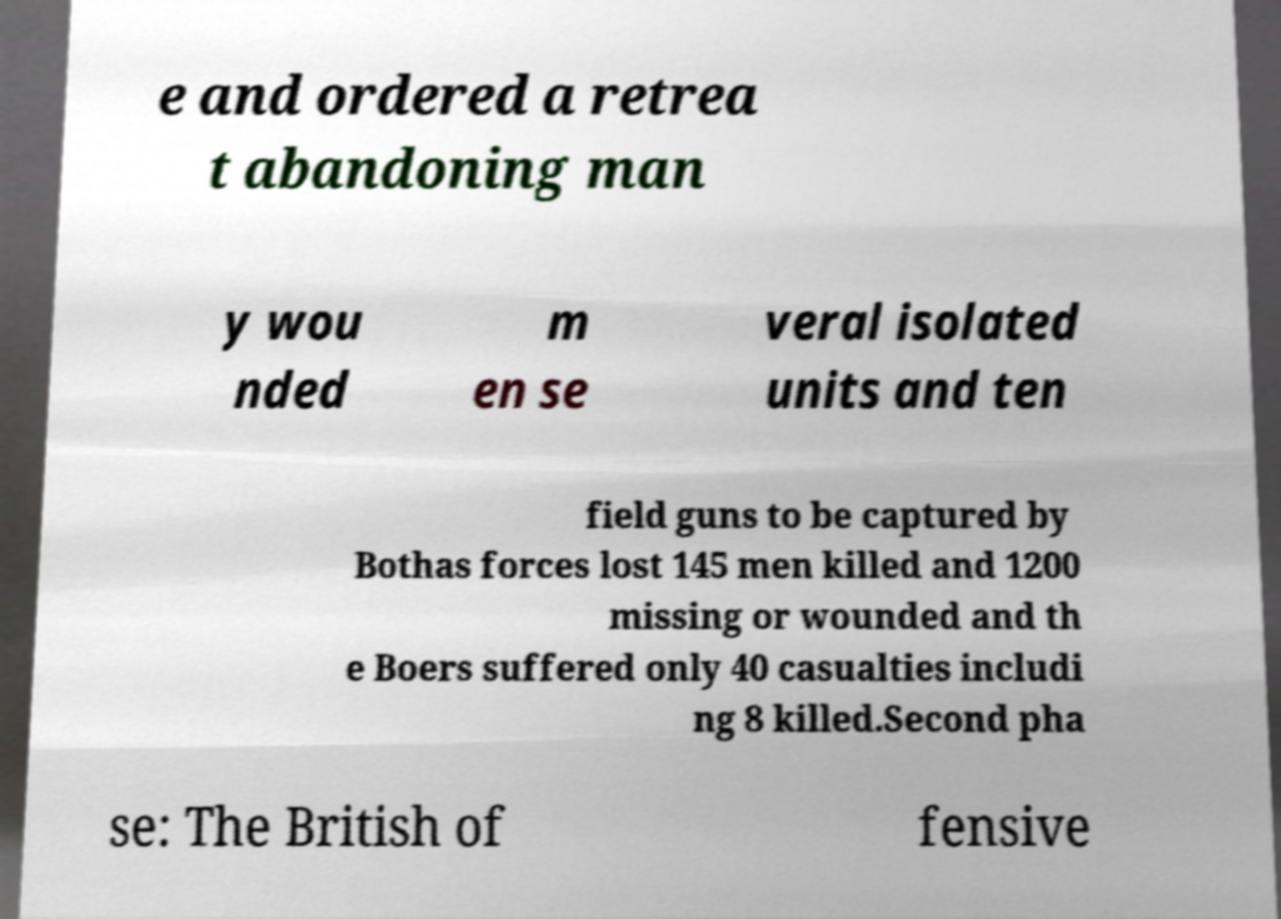Could you assist in decoding the text presented in this image and type it out clearly? e and ordered a retrea t abandoning man y wou nded m en se veral isolated units and ten field guns to be captured by Bothas forces lost 145 men killed and 1200 missing or wounded and th e Boers suffered only 40 casualties includi ng 8 killed.Second pha se: The British of fensive 